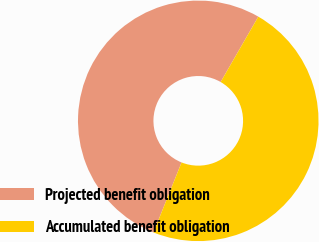Convert chart to OTSL. <chart><loc_0><loc_0><loc_500><loc_500><pie_chart><fcel>Projected benefit obligation<fcel>Accumulated benefit obligation<nl><fcel>52.25%<fcel>47.75%<nl></chart> 